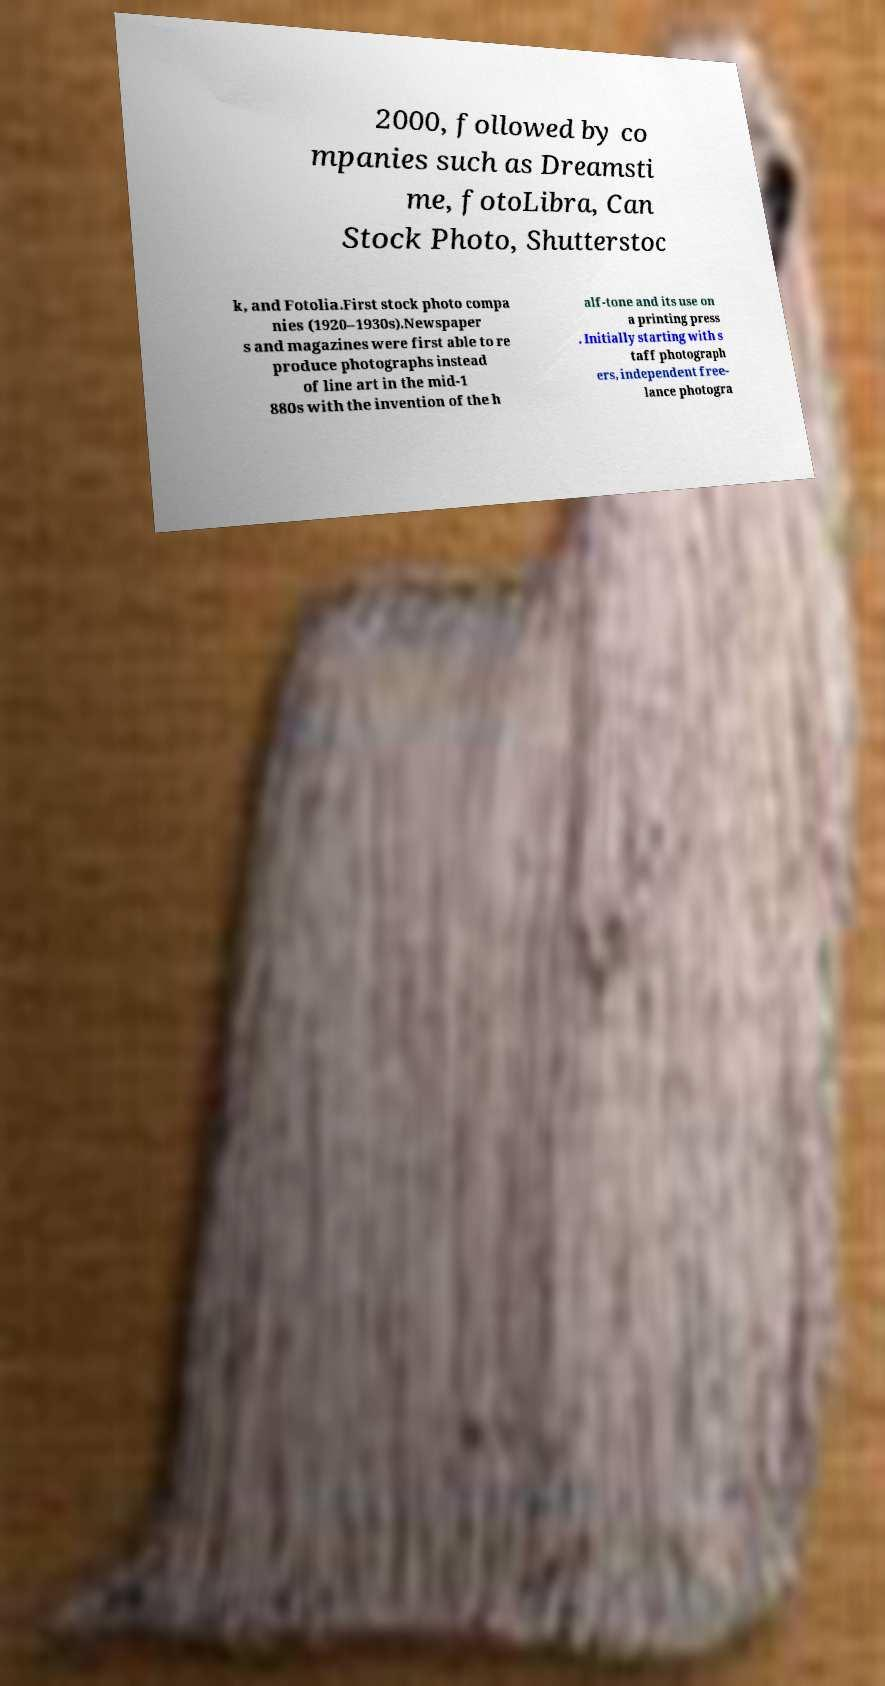Can you read and provide the text displayed in the image?This photo seems to have some interesting text. Can you extract and type it out for me? 2000, followed by co mpanies such as Dreamsti me, fotoLibra, Can Stock Photo, Shutterstoc k, and Fotolia.First stock photo compa nies (1920–1930s).Newspaper s and magazines were first able to re produce photographs instead of line art in the mid-1 880s with the invention of the h alf-tone and its use on a printing press . Initially starting with s taff photograph ers, independent free- lance photogra 